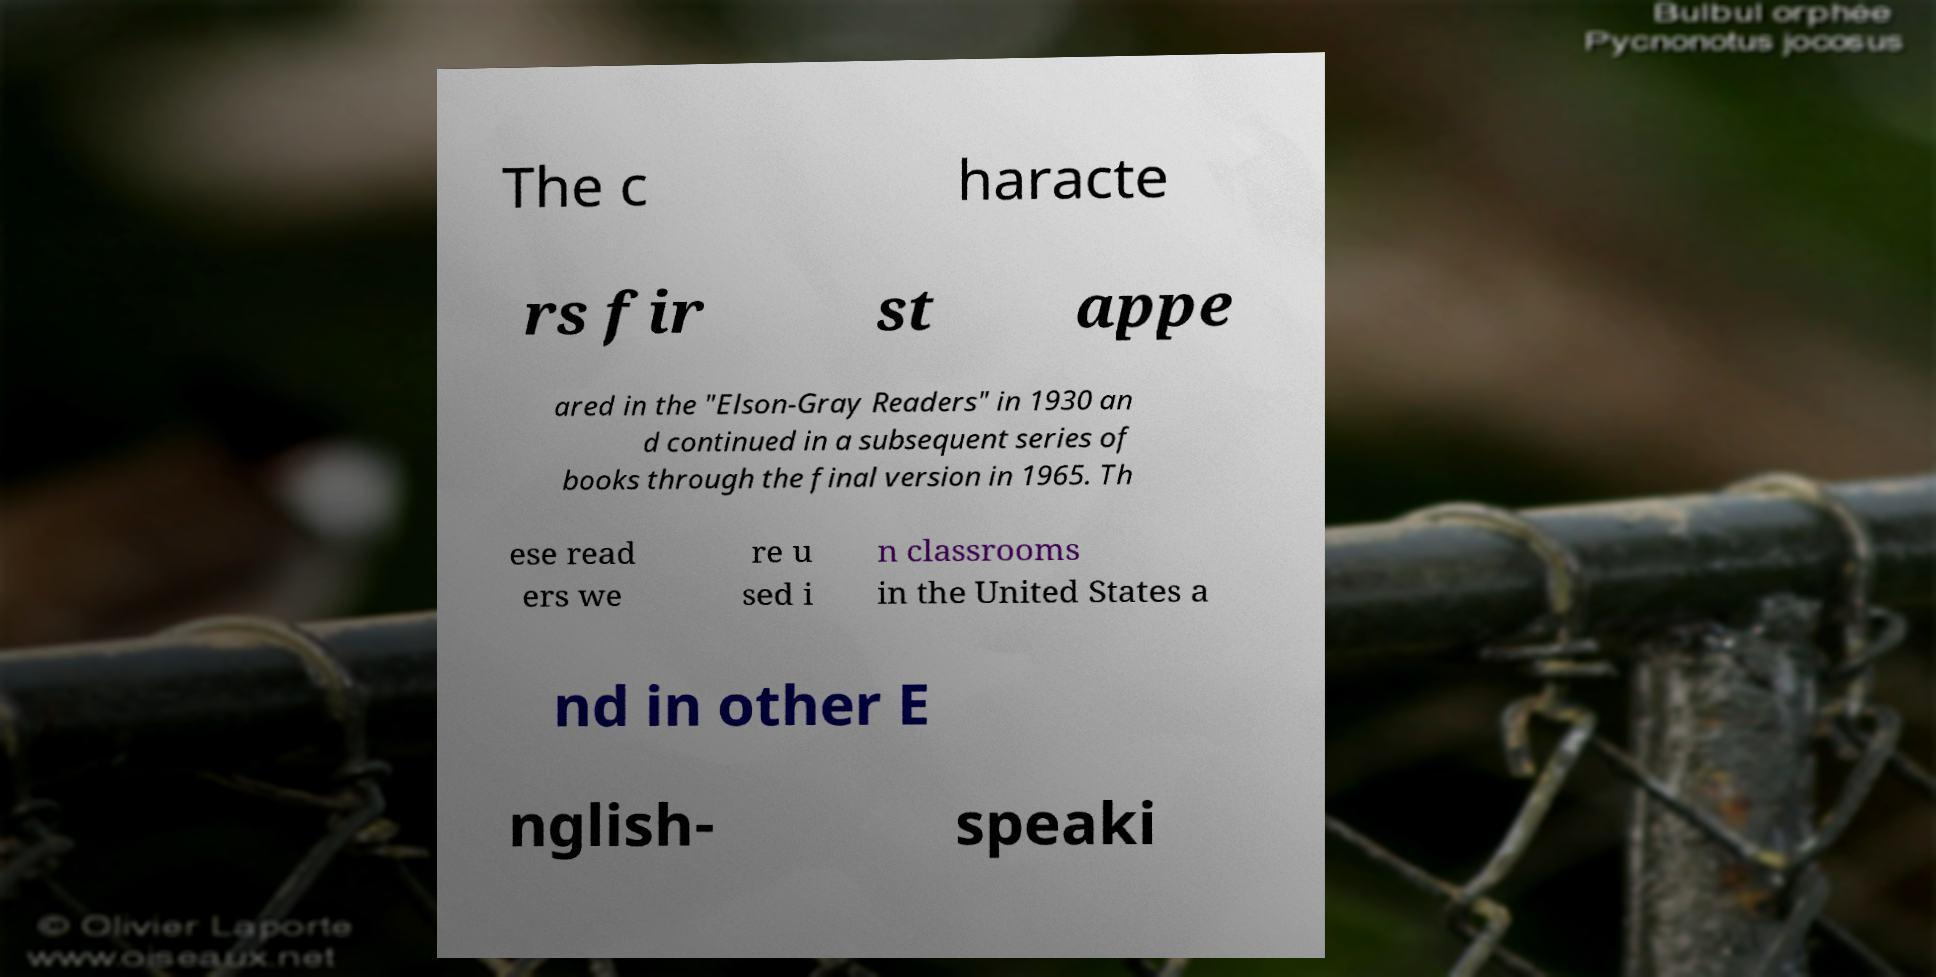There's text embedded in this image that I need extracted. Can you transcribe it verbatim? The c haracte rs fir st appe ared in the "Elson-Gray Readers" in 1930 an d continued in a subsequent series of books through the final version in 1965. Th ese read ers we re u sed i n classrooms in the United States a nd in other E nglish- speaki 